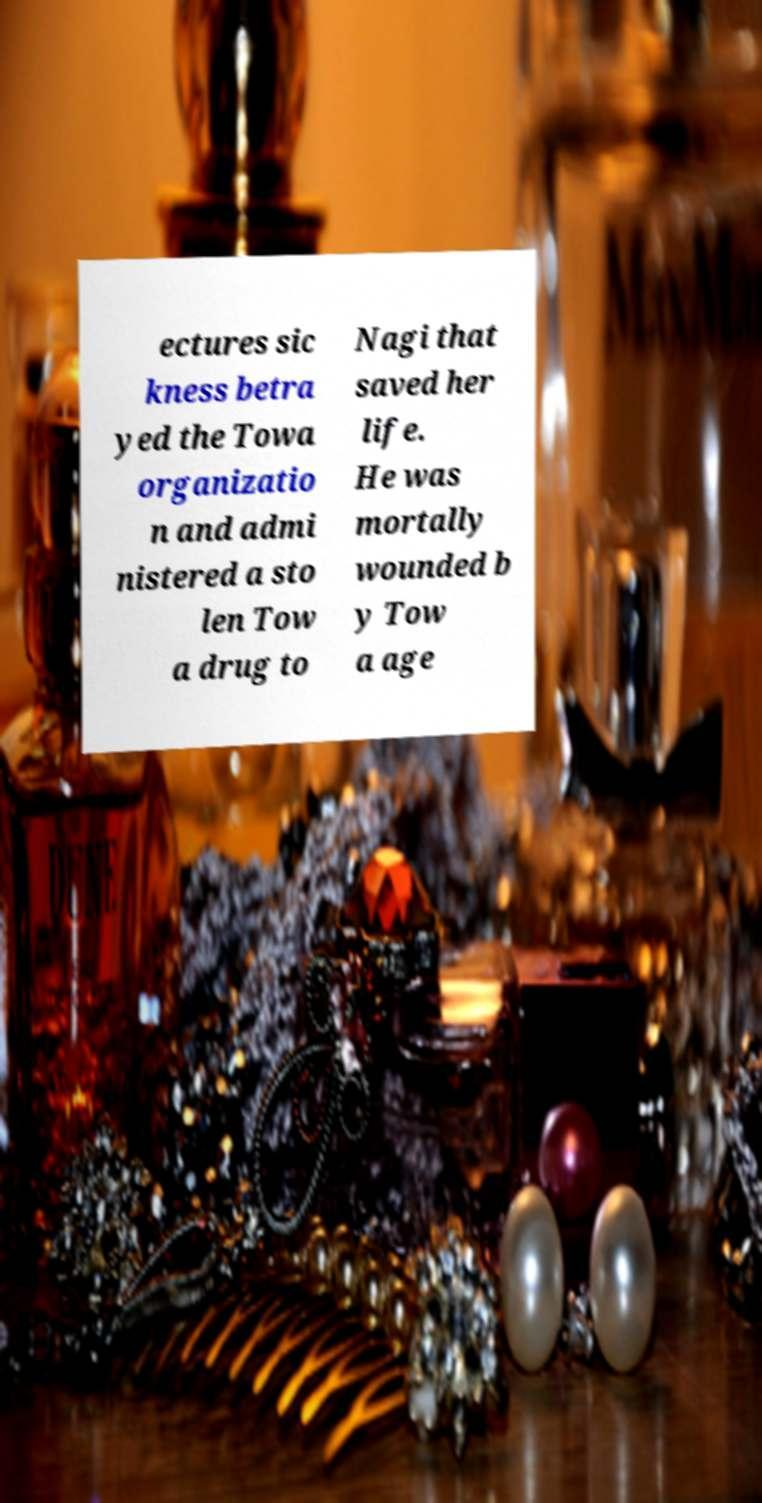Please read and relay the text visible in this image. What does it say? ectures sic kness betra yed the Towa organizatio n and admi nistered a sto len Tow a drug to Nagi that saved her life. He was mortally wounded b y Tow a age 